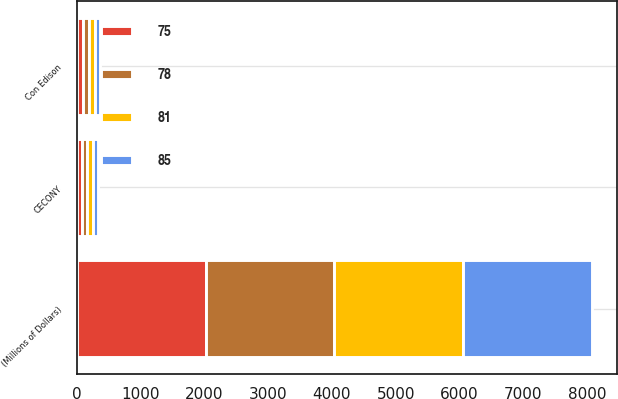Convert chart. <chart><loc_0><loc_0><loc_500><loc_500><stacked_bar_chart><ecel><fcel>(Millions of Dollars)<fcel>Con Edison<fcel>CECONY<nl><fcel>81<fcel>2016<fcel>95<fcel>85<nl><fcel>75<fcel>2017<fcel>93<fcel>83<nl><fcel>78<fcel>2018<fcel>91<fcel>81<nl><fcel>85<fcel>2019<fcel>88<fcel>78<nl></chart> 